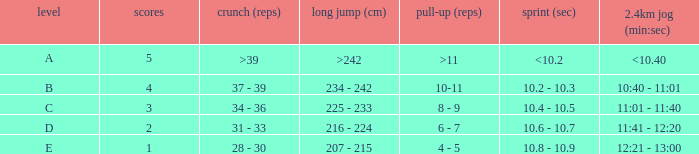Tell me the shuttle run with grade c 10.4 - 10.5. 